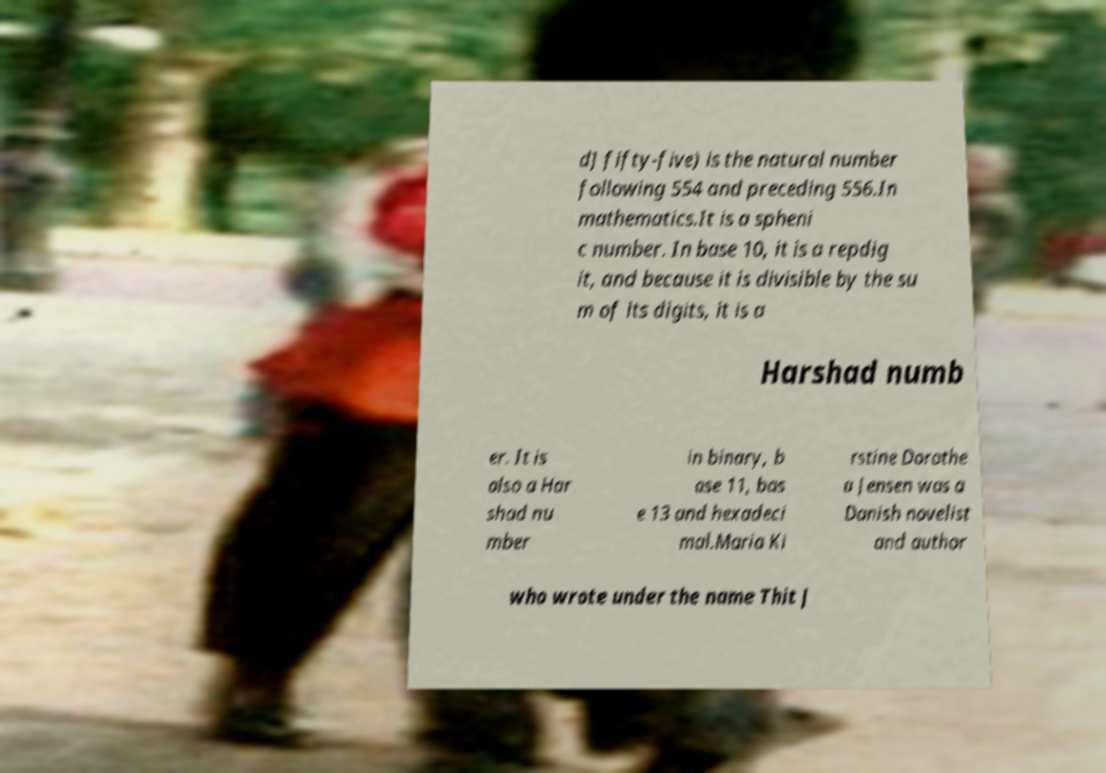Could you extract and type out the text from this image? d] fifty-five) is the natural number following 554 and preceding 556.In mathematics.It is a spheni c number. In base 10, it is a repdig it, and because it is divisible by the su m of its digits, it is a Harshad numb er. It is also a Har shad nu mber in binary, b ase 11, bas e 13 and hexadeci mal.Maria Ki rstine Dorothe a Jensen was a Danish novelist and author who wrote under the name Thit J 